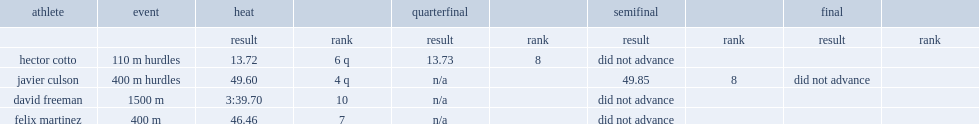What was the result that hector cotto got in the quarterfinal in the 110m event? 13.73. I'm looking to parse the entire table for insights. Could you assist me with that? {'header': ['athlete', 'event', 'heat', '', 'quarterfinal', '', 'semifinal', '', 'final', ''], 'rows': [['', '', 'result', 'rank', 'result', 'rank', 'result', 'rank', 'result', 'rank'], ['hector cotto', '110 m hurdles', '13.72', '6 q', '13.73', '8', 'did not advance', '', '', ''], ['javier culson', '400 m hurdles', '49.60', '4 q', 'n/a', '', '49.85', '8', 'did not advance', ''], ['david freeman', '1500 m', '3:39.70', '10', 'n/a', '', 'did not advance', '', '', ''], ['felix martinez', '400 m', '46.46', '7', 'n/a', '', 'did not advance', '', '', '']]} What is the result for david freeman finishing the 1500 m? 3:39.70. 